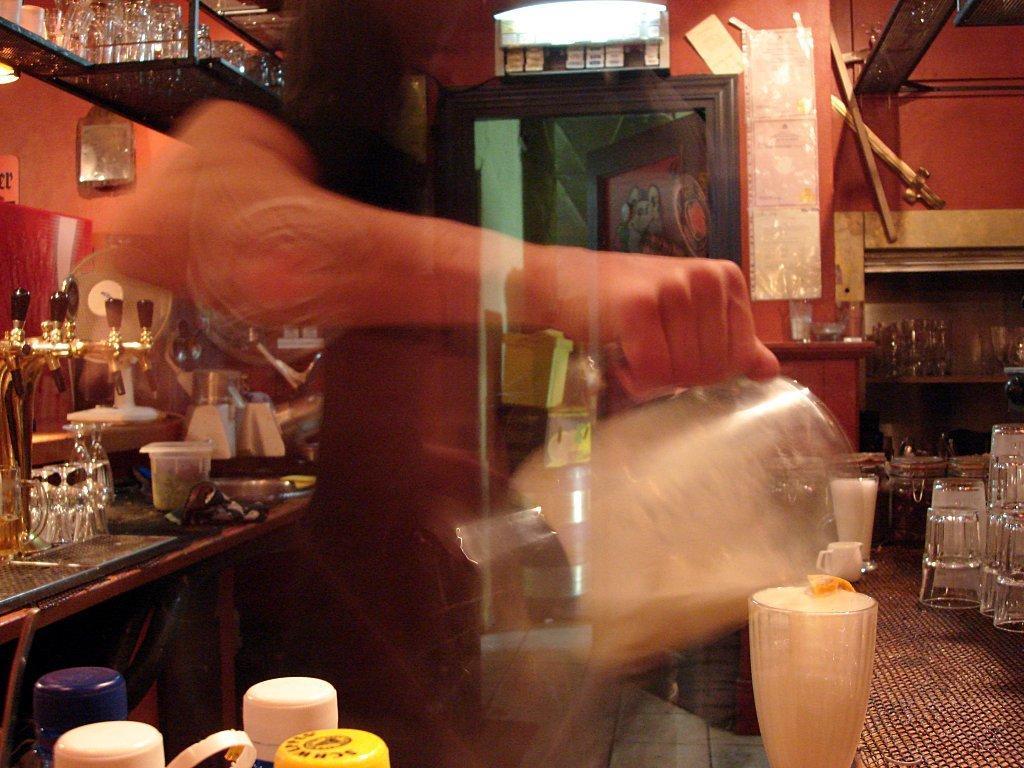Could you give a brief overview of what you see in this image? In the foreground we can see jars, glasses, kitchen, table and a blurred image of a person. In the middle of the picture we can see taps, jars, mixtures and glasses. In the background we can see doors, wall, posters, ventilator, glasses and shelves. 